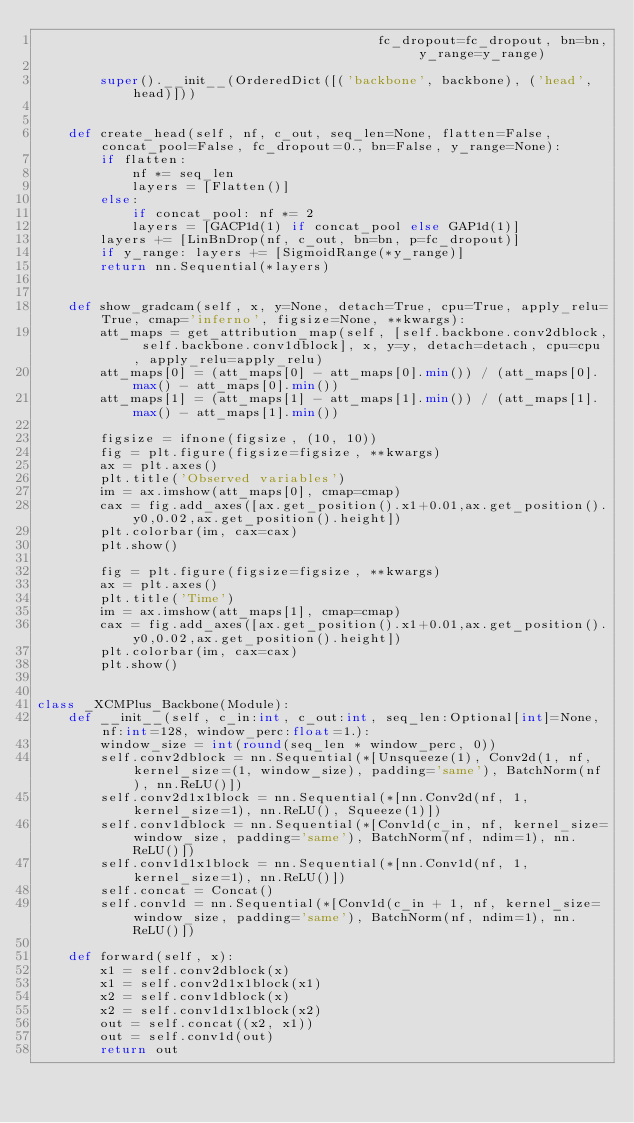<code> <loc_0><loc_0><loc_500><loc_500><_Python_>                                           fc_dropout=fc_dropout, bn=bn, y_range=y_range)

        super().__init__(OrderedDict([('backbone', backbone), ('head', head)]))


    def create_head(self, nf, c_out, seq_len=None, flatten=False, concat_pool=False, fc_dropout=0., bn=False, y_range=None):
        if flatten:
            nf *= seq_len
            layers = [Flatten()]
        else:
            if concat_pool: nf *= 2
            layers = [GACP1d(1) if concat_pool else GAP1d(1)]
        layers += [LinBnDrop(nf, c_out, bn=bn, p=fc_dropout)]
        if y_range: layers += [SigmoidRange(*y_range)]
        return nn.Sequential(*layers)


    def show_gradcam(self, x, y=None, detach=True, cpu=True, apply_relu=True, cmap='inferno', figsize=None, **kwargs):
        att_maps = get_attribution_map(self, [self.backbone.conv2dblock, self.backbone.conv1dblock], x, y=y, detach=detach, cpu=cpu, apply_relu=apply_relu)
        att_maps[0] = (att_maps[0] - att_maps[0].min()) / (att_maps[0].max() - att_maps[0].min())
        att_maps[1] = (att_maps[1] - att_maps[1].min()) / (att_maps[1].max() - att_maps[1].min())

        figsize = ifnone(figsize, (10, 10))
        fig = plt.figure(figsize=figsize, **kwargs)
        ax = plt.axes()
        plt.title('Observed variables')
        im = ax.imshow(att_maps[0], cmap=cmap)
        cax = fig.add_axes([ax.get_position().x1+0.01,ax.get_position().y0,0.02,ax.get_position().height])
        plt.colorbar(im, cax=cax)
        plt.show()

        fig = plt.figure(figsize=figsize, **kwargs)
        ax = plt.axes()
        plt.title('Time')
        im = ax.imshow(att_maps[1], cmap=cmap)
        cax = fig.add_axes([ax.get_position().x1+0.01,ax.get_position().y0,0.02,ax.get_position().height])
        plt.colorbar(im, cax=cax)
        plt.show()


class _XCMPlus_Backbone(Module):
    def __init__(self, c_in:int, c_out:int, seq_len:Optional[int]=None, nf:int=128, window_perc:float=1.):
        window_size = int(round(seq_len * window_perc, 0))
        self.conv2dblock = nn.Sequential(*[Unsqueeze(1), Conv2d(1, nf, kernel_size=(1, window_size), padding='same'), BatchNorm(nf), nn.ReLU()])
        self.conv2d1x1block = nn.Sequential(*[nn.Conv2d(nf, 1, kernel_size=1), nn.ReLU(), Squeeze(1)])
        self.conv1dblock = nn.Sequential(*[Conv1d(c_in, nf, kernel_size=window_size, padding='same'), BatchNorm(nf, ndim=1), nn.ReLU()])
        self.conv1d1x1block = nn.Sequential(*[nn.Conv1d(nf, 1, kernel_size=1), nn.ReLU()])
        self.concat = Concat()
        self.conv1d = nn.Sequential(*[Conv1d(c_in + 1, nf, kernel_size=window_size, padding='same'), BatchNorm(nf, ndim=1), nn.ReLU()])

    def forward(self, x):
        x1 = self.conv2dblock(x)
        x1 = self.conv2d1x1block(x1)
        x2 = self.conv1dblock(x)
        x2 = self.conv1d1x1block(x2)
        out = self.concat((x2, x1))
        out = self.conv1d(out)
        return out</code> 